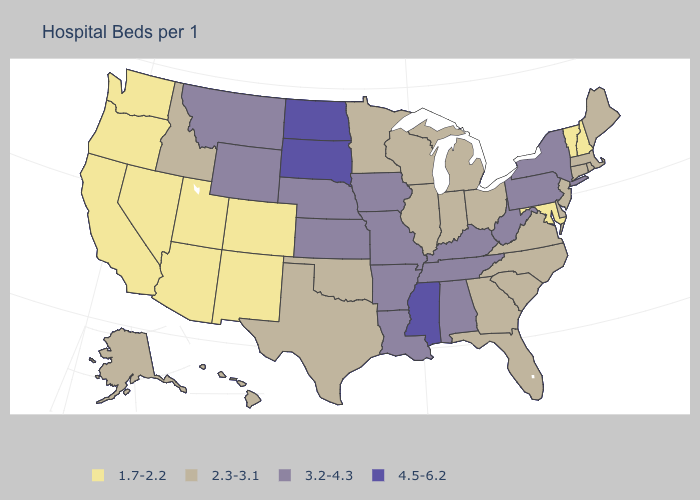What is the value of Connecticut?
Give a very brief answer. 2.3-3.1. Which states have the lowest value in the USA?
Quick response, please. Arizona, California, Colorado, Maryland, Nevada, New Hampshire, New Mexico, Oregon, Utah, Vermont, Washington. Does the map have missing data?
Write a very short answer. No. Which states have the lowest value in the USA?
Write a very short answer. Arizona, California, Colorado, Maryland, Nevada, New Hampshire, New Mexico, Oregon, Utah, Vermont, Washington. Does Oregon have the highest value in the West?
Write a very short answer. No. Does South Dakota have the highest value in the USA?
Give a very brief answer. Yes. What is the value of Rhode Island?
Short answer required. 2.3-3.1. Is the legend a continuous bar?
Keep it brief. No. What is the value of Oklahoma?
Write a very short answer. 2.3-3.1. Which states have the lowest value in the MidWest?
Give a very brief answer. Illinois, Indiana, Michigan, Minnesota, Ohio, Wisconsin. What is the value of Illinois?
Concise answer only. 2.3-3.1. What is the value of Louisiana?
Write a very short answer. 3.2-4.3. What is the lowest value in the Northeast?
Keep it brief. 1.7-2.2. How many symbols are there in the legend?
Write a very short answer. 4. Does Maryland have a lower value than Indiana?
Keep it brief. Yes. 